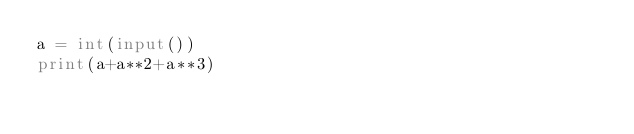Convert code to text. <code><loc_0><loc_0><loc_500><loc_500><_Python_>a = int(input())
print(a+a**2+a**3)</code> 